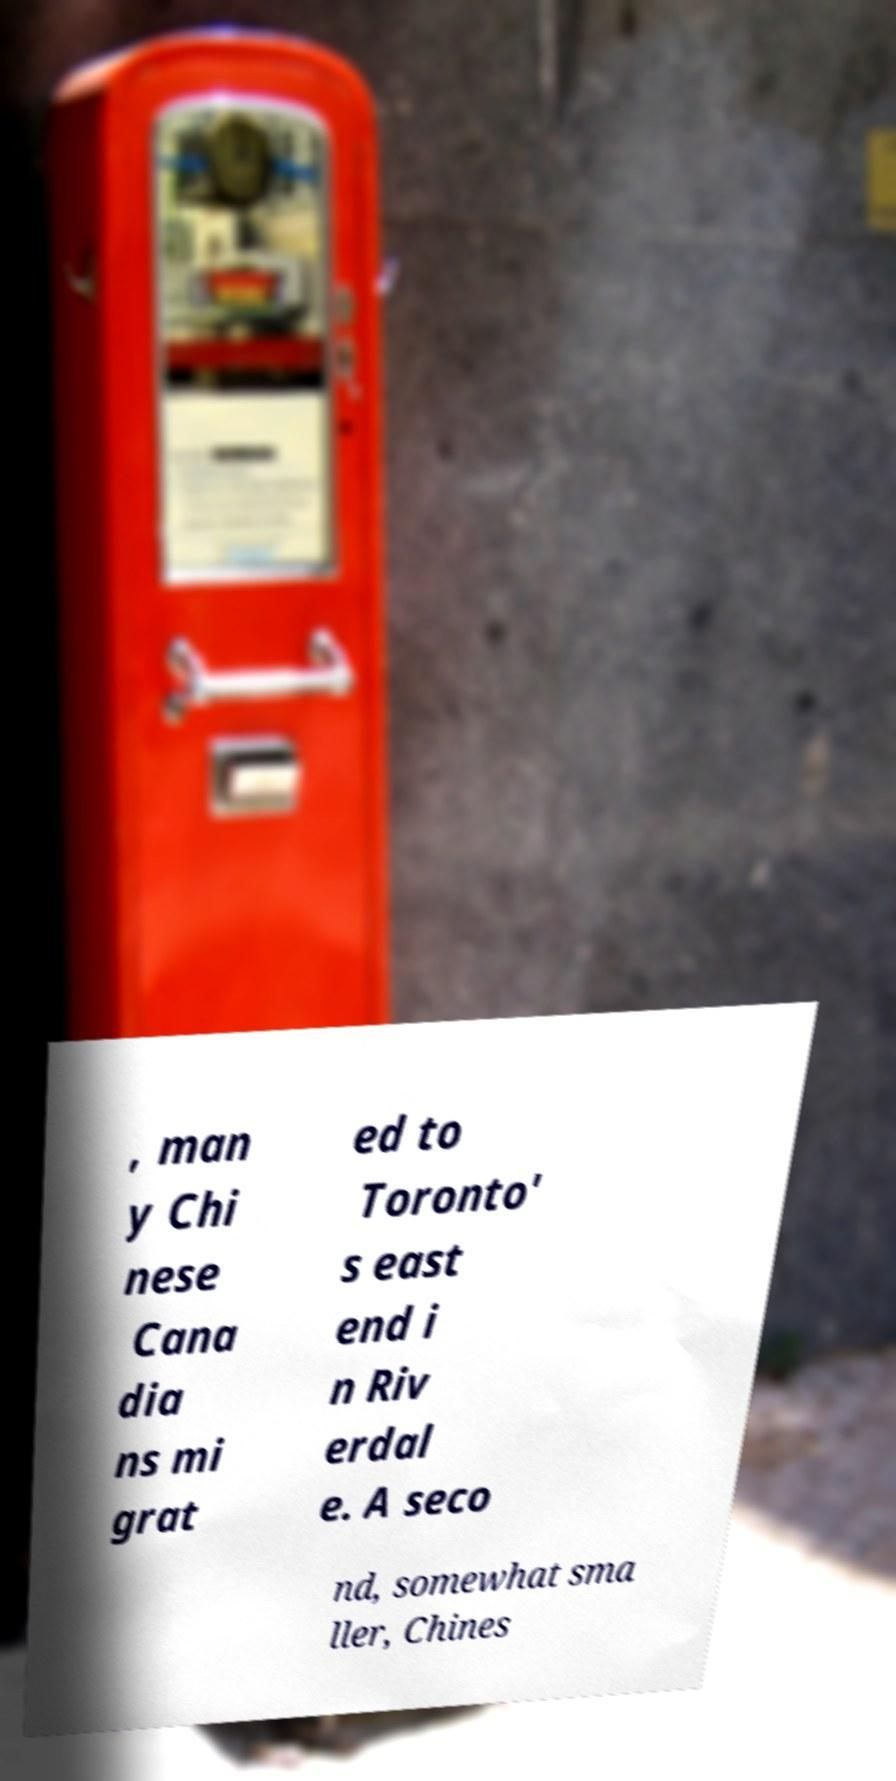Can you read and provide the text displayed in the image?This photo seems to have some interesting text. Can you extract and type it out for me? , man y Chi nese Cana dia ns mi grat ed to Toronto' s east end i n Riv erdal e. A seco nd, somewhat sma ller, Chines 